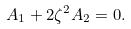<formula> <loc_0><loc_0><loc_500><loc_500>A _ { 1 } + 2 \zeta ^ { 2 } A _ { 2 } = 0 .</formula> 